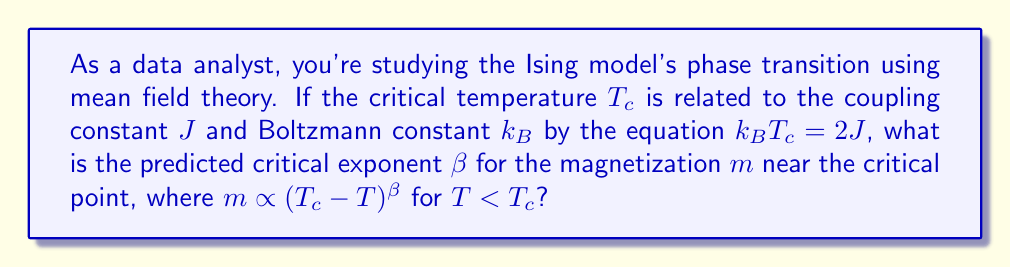Could you help me with this problem? To find the critical exponent $\beta$, let's follow these steps:

1) In mean field theory, the self-consistent equation for magnetization is:
   $$m = \tanh(\frac{Jm}{k_B T})$$

2) Near the critical point, $m$ is small, so we can expand $\tanh(x)$ as:
   $$\tanh(x) \approx x - \frac{1}{3}x^3 + ...$$

3) Substituting this into our self-consistent equation:
   $$m \approx \frac{Jm}{k_B T} - \frac{1}{3}(\frac{Jm}{k_B T})^3$$

4) Rearranging terms:
   $$m(1 - \frac{J}{k_B T}) + \frac{1}{3}(\frac{J}{k_B T})^3 m^3 \approx 0$$

5) Let $t = \frac{T_c - T}{T_c}$ be the reduced temperature. Using $k_B T_c = 2J$, we can write:
   $$\frac{J}{k_B T} = \frac{1}{2-t}$$

6) Substituting this into our equation:
   $$m(\frac{t}{2-t}) + \frac{1}{3}(\frac{1}{2-t})^3 m^3 \approx 0$$

7) For small $t$, $\frac{1}{2-t} \approx \frac{1}{2}(1 + \frac{t}{2})$, so:
   $$\frac{t}{2}m + \frac{1}{24}(1 + \frac{3t}{2})m^3 \approx 0$$

8) To leading order in $t$:
   $$\frac{t}{2}m + \frac{1}{24}m^3 \approx 0$$

9) Solving for $m$:
   $$m^2 \approx 12t$$

10) Therefore:
    $$m \propto \sqrt{t} = \sqrt{T_c - T}$$

11) Comparing with $m \propto (T_c - T)^\beta$, we see that $\beta = \frac{1}{2}$.
Answer: $\beta = \frac{1}{2}$ 